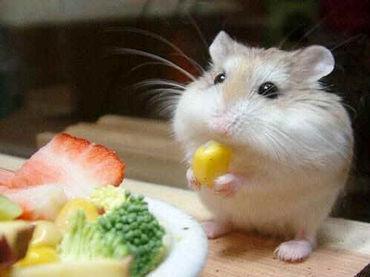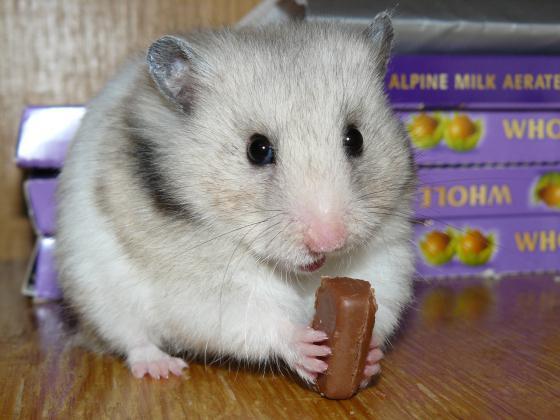The first image is the image on the left, the second image is the image on the right. Evaluate the accuracy of this statement regarding the images: "An image contains a rodent wearing a small hat.". Is it true? Answer yes or no. No. The first image is the image on the left, the second image is the image on the right. For the images shown, is this caption "One image shows a hamster in a chair dining at a kind of table and wearing a costume hat." true? Answer yes or no. No. 